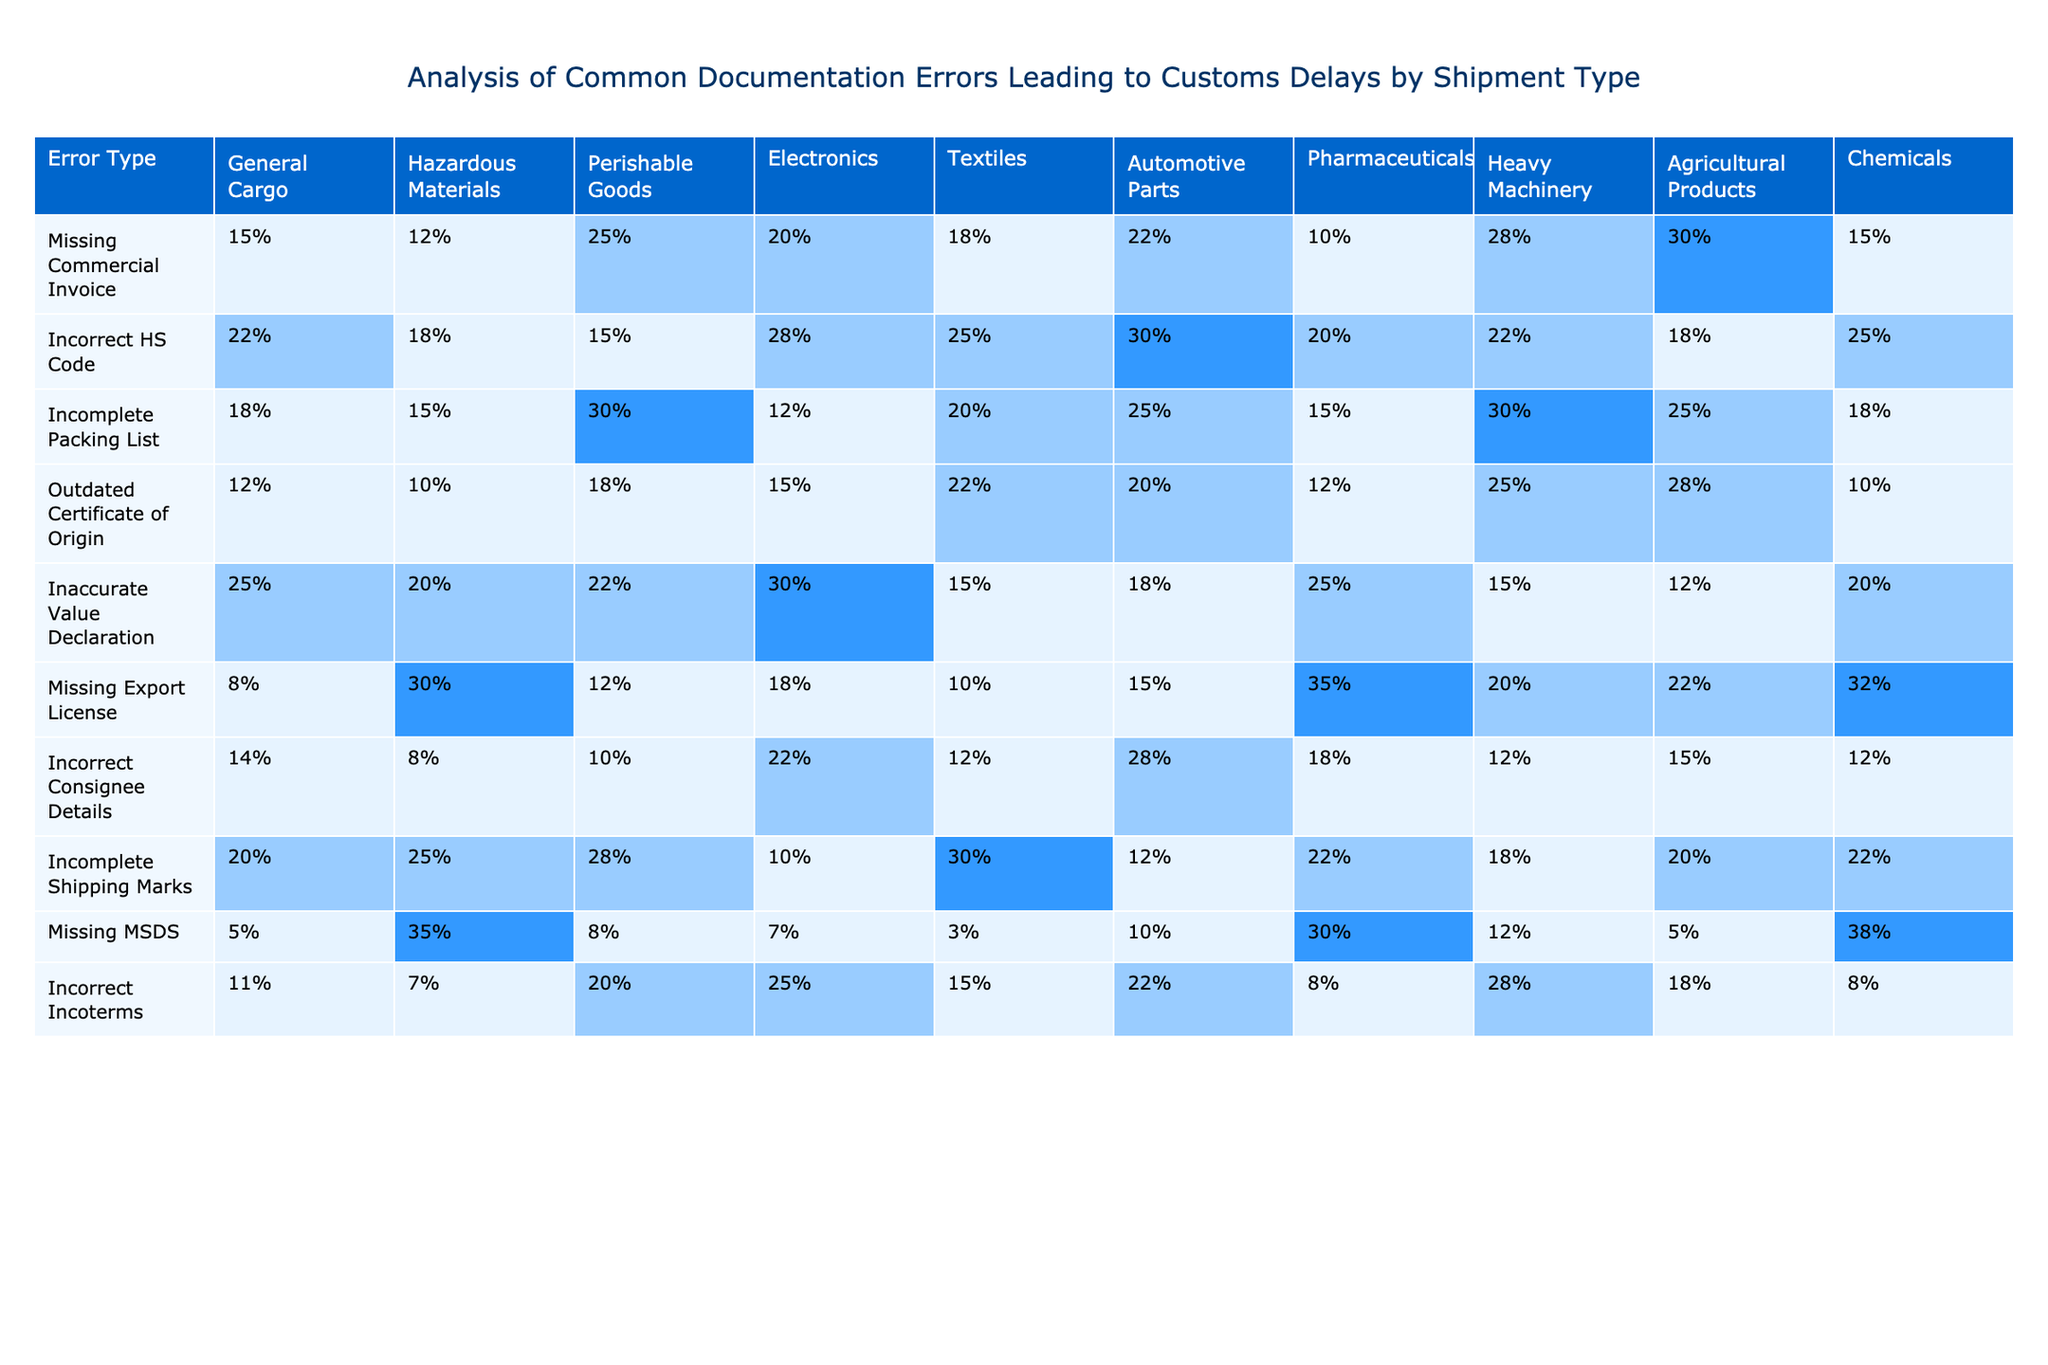What is the highest percentage of missing commercial invoice among the shipment types? To find the highest percentage for missing commercial invoice, I look at the corresponding column and identify the maximum value. Perishable Goods has 25%, which is the largest value in that column.
Answer: 25% Which shipment type has the lowest percentage of incorrect HS codes? I examine the column for incorrect HS codes and find the lowest value. Hazardous Materials has the lowest percentage of 18%.
Answer: 18% How many errors have over 30% in the missing export license category? I check the missing export license column and count the shipment types with percentages over 30%. Hazardous Materials and Pharmaceuticals are the only two types, as both exceed 30%.
Answer: 2 Which shipment type has the highest percentage of incomplete packing lists? I look through the incomplete packing list column to find the maximum value, which belongs to Perishable Goods with 30%.
Answer: Perishable Goods What is the average percentage of outdated certificate of origin across all shipment types? I sum the percentages for outdated certificate of origin (12% + 10% + 18% + 15% + 22% + 12% + 12% + 25% + 28% + 10% =  0.245) and then divide by the number of shipment types (10). Thus, the average is 24.5%, which is about 24.5%.
Answer: 24.5% Is there a shipment type that has no missing MSDS? I observe the missing MSDS column and find the values for all shipment types. Perishable Goods has 8%, indicating there are no shipment types with 0% missing MSDS.
Answer: No Which error type has the highest percentage for Automotive Parts? I scan the row corresponding to Automotive Parts to find the maximum value. The incorrect HS code is 30%, which is the highest for that shipment type.
Answer: Incorrect HS Code Which shipment type combination has the smallest percentage in the incorrect Incoterms category? In the incorrect Incoterms column, I evaluate all values for differences, recognizing that Perishable Goods has the lowest percentage at 20%.
Answer: 20% How many error types have percentages greater than 20% for General Cargo? I analyze the General Cargo row for each error type and count how many exceed 20%, identifying that missing commercial invoice, incorrect HS code, incomplete shipping marks, and inaccurate value declaration do, which totals 4.
Answer: 4 Which error type shows the highest variability among all shipment types? I calculate the range (max - min) for each error type to determine variability. Missing MSDS varies from 3% to 38%, resulting in 35%, which is the highest range among the columns.
Answer: Missing MSDS 